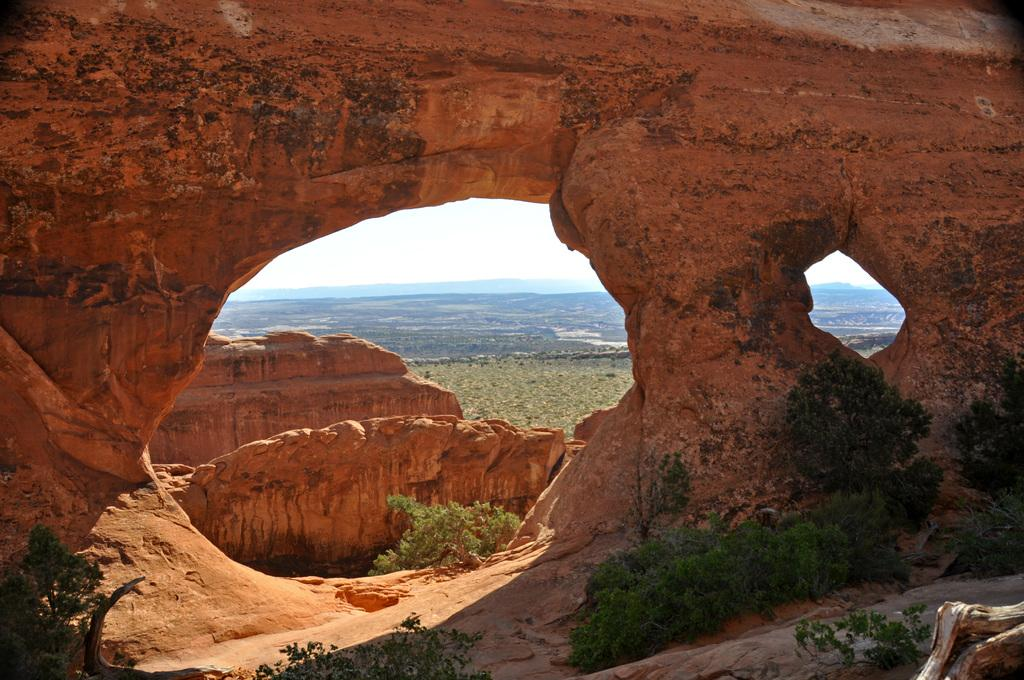What type of natural formations can be seen in the image? There are caves in the image. What other natural elements are present in the image? There are trees in the image. What can be seen in the background of the image? The sky is visible in the background of the image. Where is the vase placed in the image? There is no vase present in the image. What rule is being enforced in the image? There is no rule being enforced in the image; it is a natural scene featuring caves, trees, and the sky. 